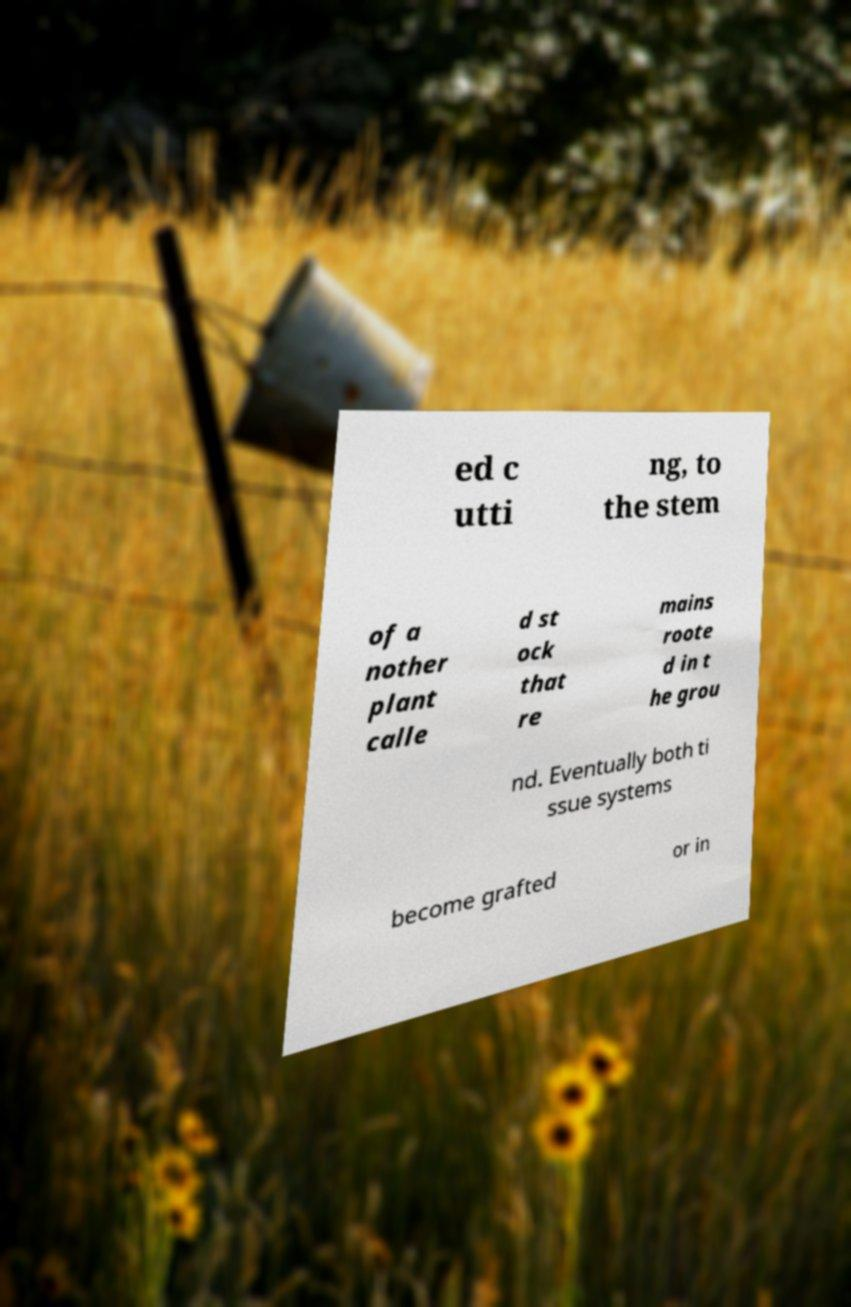Could you assist in decoding the text presented in this image and type it out clearly? ed c utti ng, to the stem of a nother plant calle d st ock that re mains roote d in t he grou nd. Eventually both ti ssue systems become grafted or in 